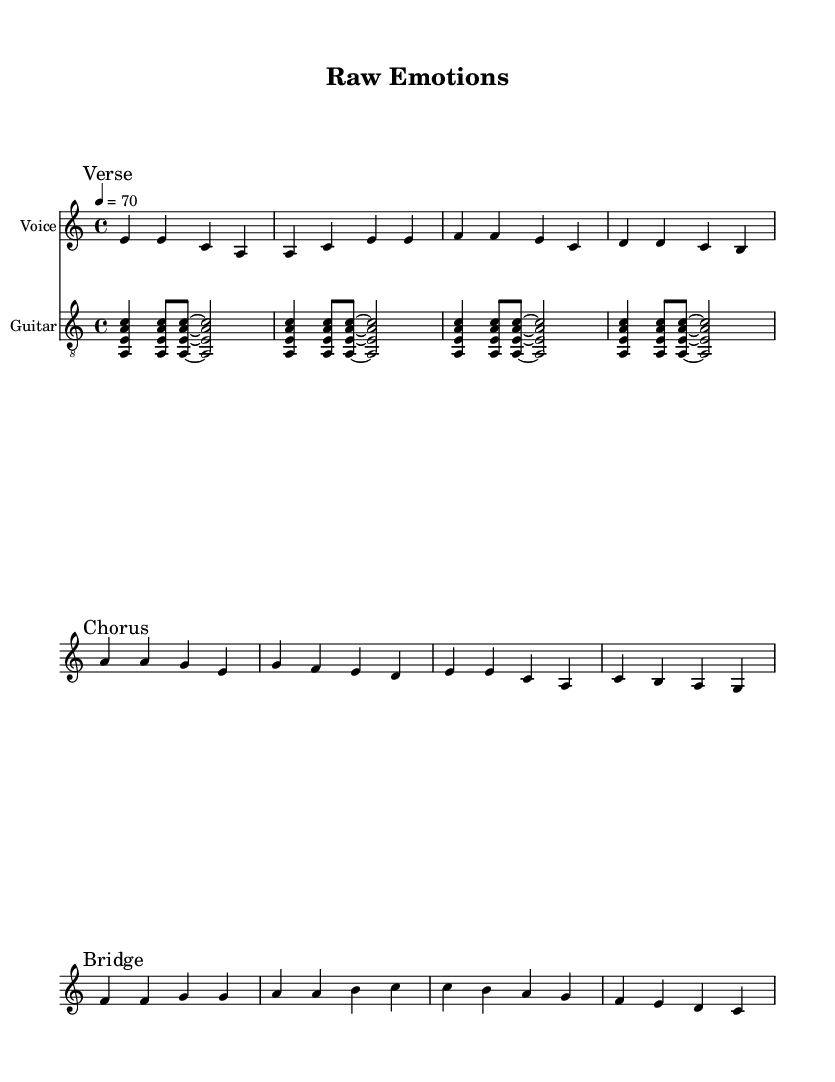What is the key signature of this music? The key signature is indicated at the beginning of the sheet music, showing a single flat which corresponds to A minor. This can be confirmed as there are no sharps and one flat, which identifies it as A minor.
Answer: A minor What is the time signature of the music? The time signature is located at the beginning and is represented as 4/4. This means there are four beats per measure and the quarter note gets the beat.
Answer: 4/4 What is the tempo marking for the piece? The tempo marking is shown in beats per minute at the start of the score, with a value of 70. This indicates how fast the music should be played.
Answer: 70 How many measures are in the verse section? The verse section consists of four measures, evident from counting the bars in the vocal staff where each grouping separated by a vertical line indicates a measure.
Answer: 4 Which vocal section follows the chorus? The sheet music shows that the next section after the chorus is labeled as the bridge, as indicated by the corresponding marking above the staff.
Answer: Bridge What type of accompaniment is used throughout the piece? The piece includes a guitar as the accompanying instrument, as shown by the additional staff labeled as "Guitar" which contains chords.
Answer: Guitar Which note does the bridge start on? The bridge starts with an F note, which can be found at the beginning of its respective section in the vocal staff.
Answer: F 